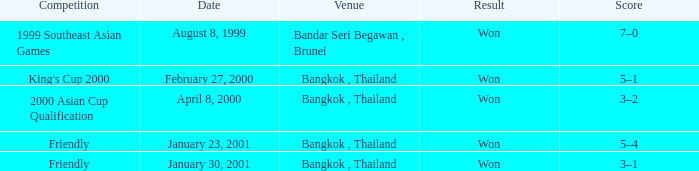What was the result from the 2000 asian cup qualification? Won. 